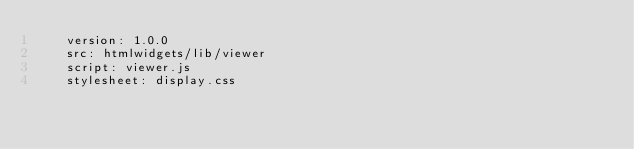Convert code to text. <code><loc_0><loc_0><loc_500><loc_500><_YAML_>    version: 1.0.0
    src: htmlwidgets/lib/viewer
    script: viewer.js
    stylesheet: display.css
</code> 